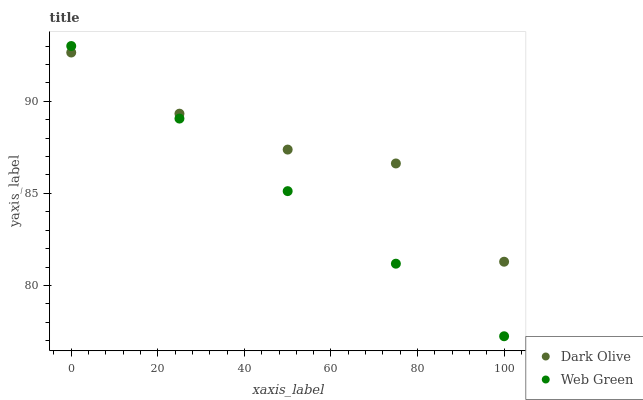Does Web Green have the minimum area under the curve?
Answer yes or no. Yes. Does Dark Olive have the maximum area under the curve?
Answer yes or no. Yes. Does Web Green have the maximum area under the curve?
Answer yes or no. No. Is Web Green the smoothest?
Answer yes or no. Yes. Is Dark Olive the roughest?
Answer yes or no. Yes. Is Web Green the roughest?
Answer yes or no. No. Does Web Green have the lowest value?
Answer yes or no. Yes. Does Web Green have the highest value?
Answer yes or no. Yes. Does Web Green intersect Dark Olive?
Answer yes or no. Yes. Is Web Green less than Dark Olive?
Answer yes or no. No. Is Web Green greater than Dark Olive?
Answer yes or no. No. 